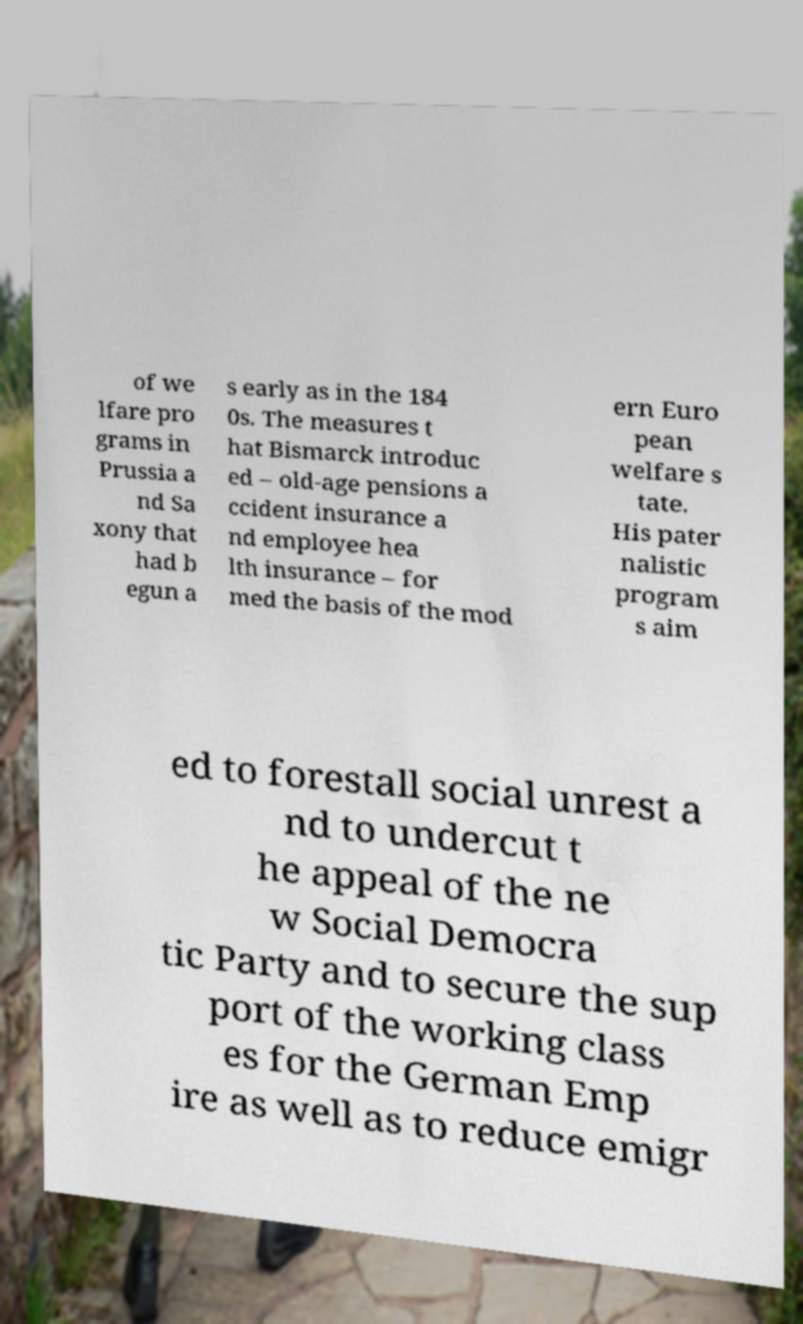Could you assist in decoding the text presented in this image and type it out clearly? of we lfare pro grams in Prussia a nd Sa xony that had b egun a s early as in the 184 0s. The measures t hat Bismarck introduc ed – old-age pensions a ccident insurance a nd employee hea lth insurance – for med the basis of the mod ern Euro pean welfare s tate. His pater nalistic program s aim ed to forestall social unrest a nd to undercut t he appeal of the ne w Social Democra tic Party and to secure the sup port of the working class es for the German Emp ire as well as to reduce emigr 